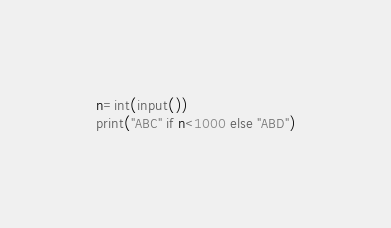Convert code to text. <code><loc_0><loc_0><loc_500><loc_500><_Python_>n=int(input())
print("ABC" if n<1000 else "ABD")</code> 